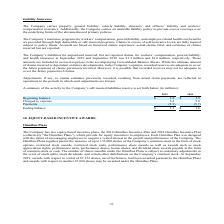From Amcon Distributing's financial document, What is the beginning balance in 2019 and 2018 respectively? The document shows two values: $1.6 and $1.5 (in millions). From the document: "insurance at September 2019 and September 2018 was $1.5 million and $1.6 million, respectively. These amounts are included in accrued expenses in the ..." Also, What are the company's respective liabilities for unpaid and incurred, but not reported claims, for workers’ compensation, general liability, and health insurance at September 2019 and September 2018? The document shows two values: $1.5 million and $1.6 million. From the document: "ember 2019 and September 2018 was $1.5 million and $1.6 million, respectively. These amounts are included in accrued expenses in the accompanying Cons..." Also, How are the company's insurance programs for workers’ compensation, general liability, and employee related health care benefits are provided? high deductible or self-insured programs.. The document states: "related health care benefits are provided through high deductible or self-insured programs. Claims in excess of self-insurance levels are fully insure..." Also, can you calculate: What is the percentage change in the beginning balance of the company's liability insurance between 2018 and 2019? To answer this question, I need to perform calculations using the financial data. The calculation is: (1.6 - 1.5)/1.5 , which equals 6.67 (percentage). This is based on the information: "ber 2019 and September 2018 was $1.5 million and $1.6 million, respectively. These amounts are included in accrued expenses in the accompanying Consolida surance at September 2019 and September 2018 w..." The key data points involved are: 1.5, 1.6. Also, can you calculate: What is the percentage change in the charged to expense value of the company's liability insurance between 2018 and 2019? To answer this question, I need to perform calculations using the financial data. The calculation is: (5.4 - 5.8)/5.8 , which equals -6.9 (percentage). This is based on the information: "Charged to expense 5.4 5.8 Charged to expense 5.4 5.8..." The key data points involved are: 5.4, 5.8. Also, can you calculate: What is the percentage change in the ending balance of the company's liability insurance between 2018 and 2019? To answer this question, I need to perform calculations using the financial data. The calculation is: (1.5 - 1.6)/1.6 , which equals -6.25 (percentage). This is based on the information: "surance at September 2019 and September 2018 was $1.5 million and $1.6 million, respectively. These amounts are included in accrued expenses in the accom ber 2019 and September 2018 was $1.5 million a..." The key data points involved are: 1.5, 1.6. 